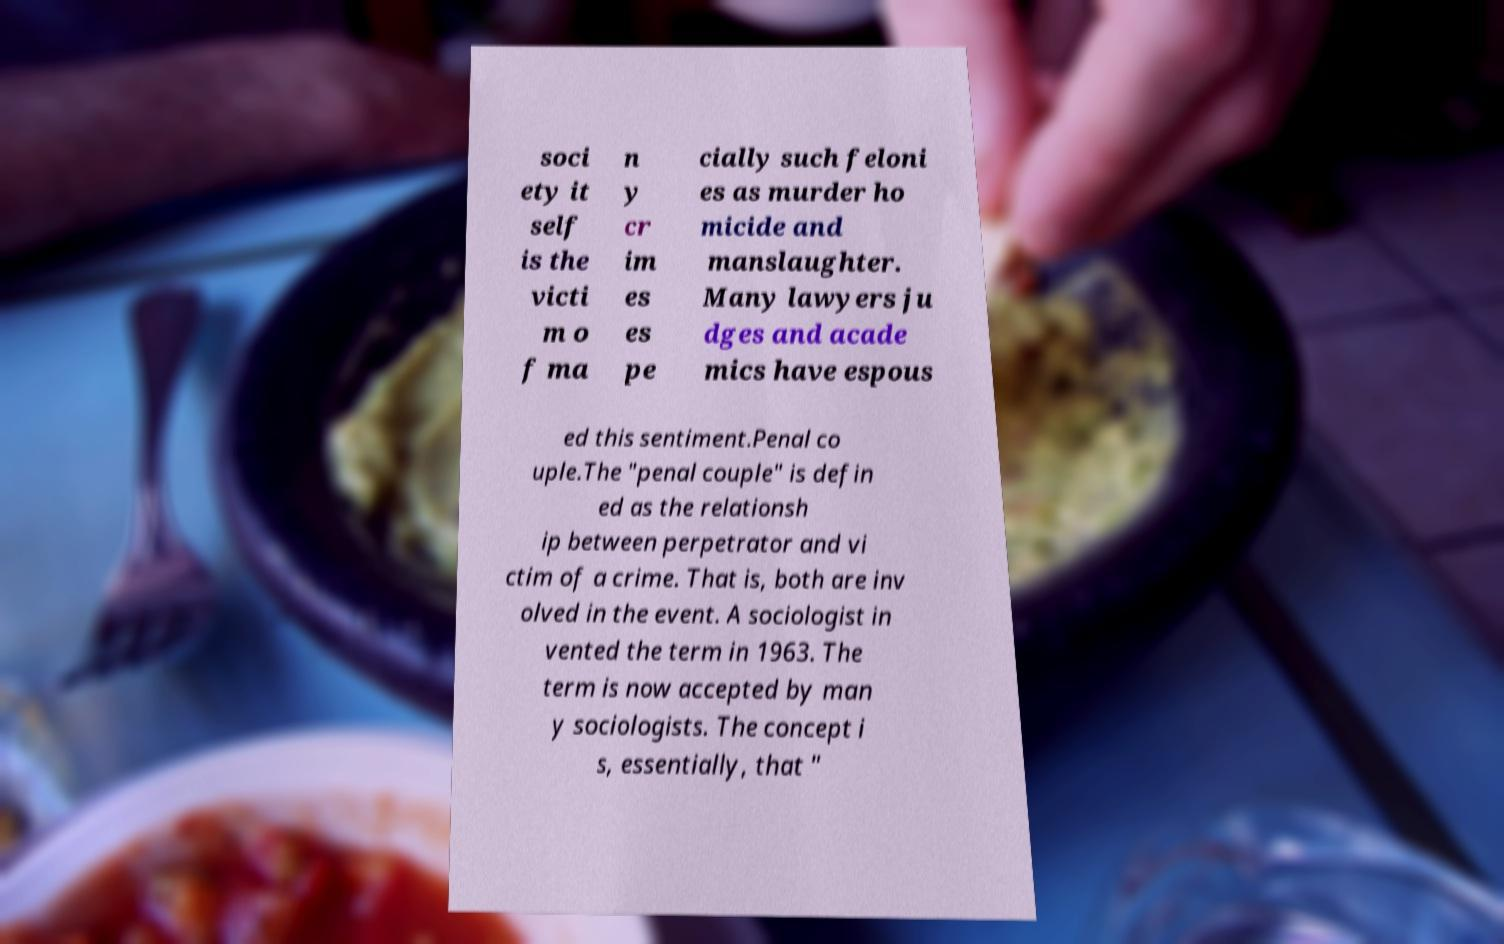What messages or text are displayed in this image? I need them in a readable, typed format. soci ety it self is the victi m o f ma n y cr im es es pe cially such feloni es as murder ho micide and manslaughter. Many lawyers ju dges and acade mics have espous ed this sentiment.Penal co uple.The "penal couple" is defin ed as the relationsh ip between perpetrator and vi ctim of a crime. That is, both are inv olved in the event. A sociologist in vented the term in 1963. The term is now accepted by man y sociologists. The concept i s, essentially, that " 